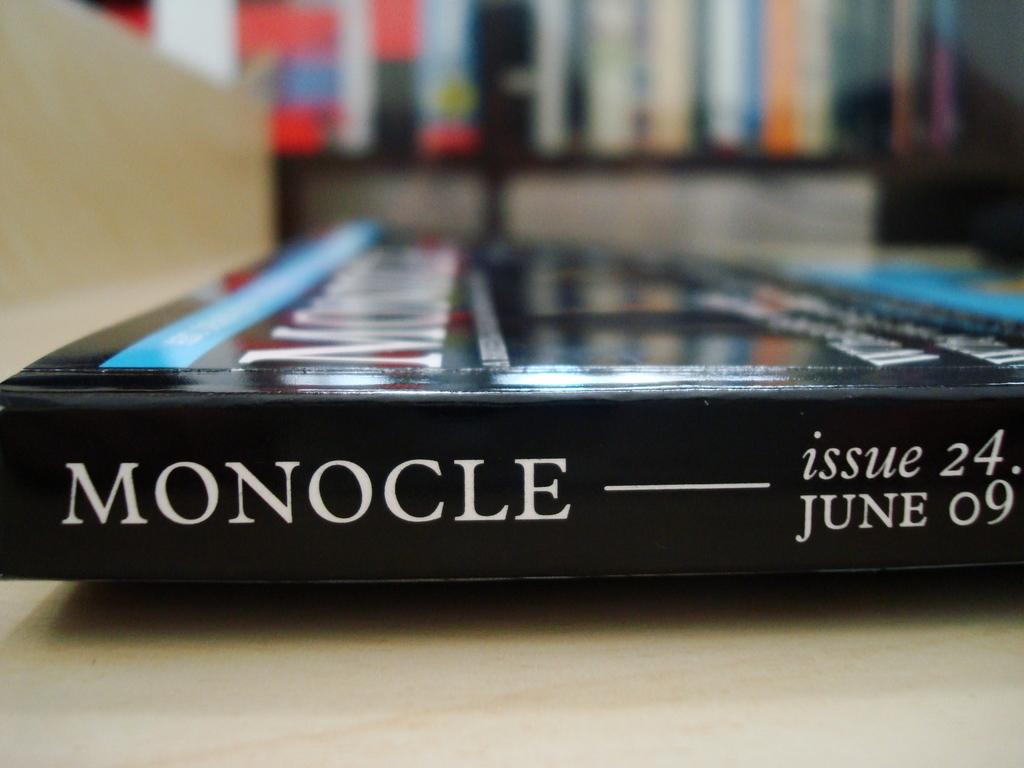<image>
Describe the image concisely. Monocle issue 24 published June 9th sits on a table. 